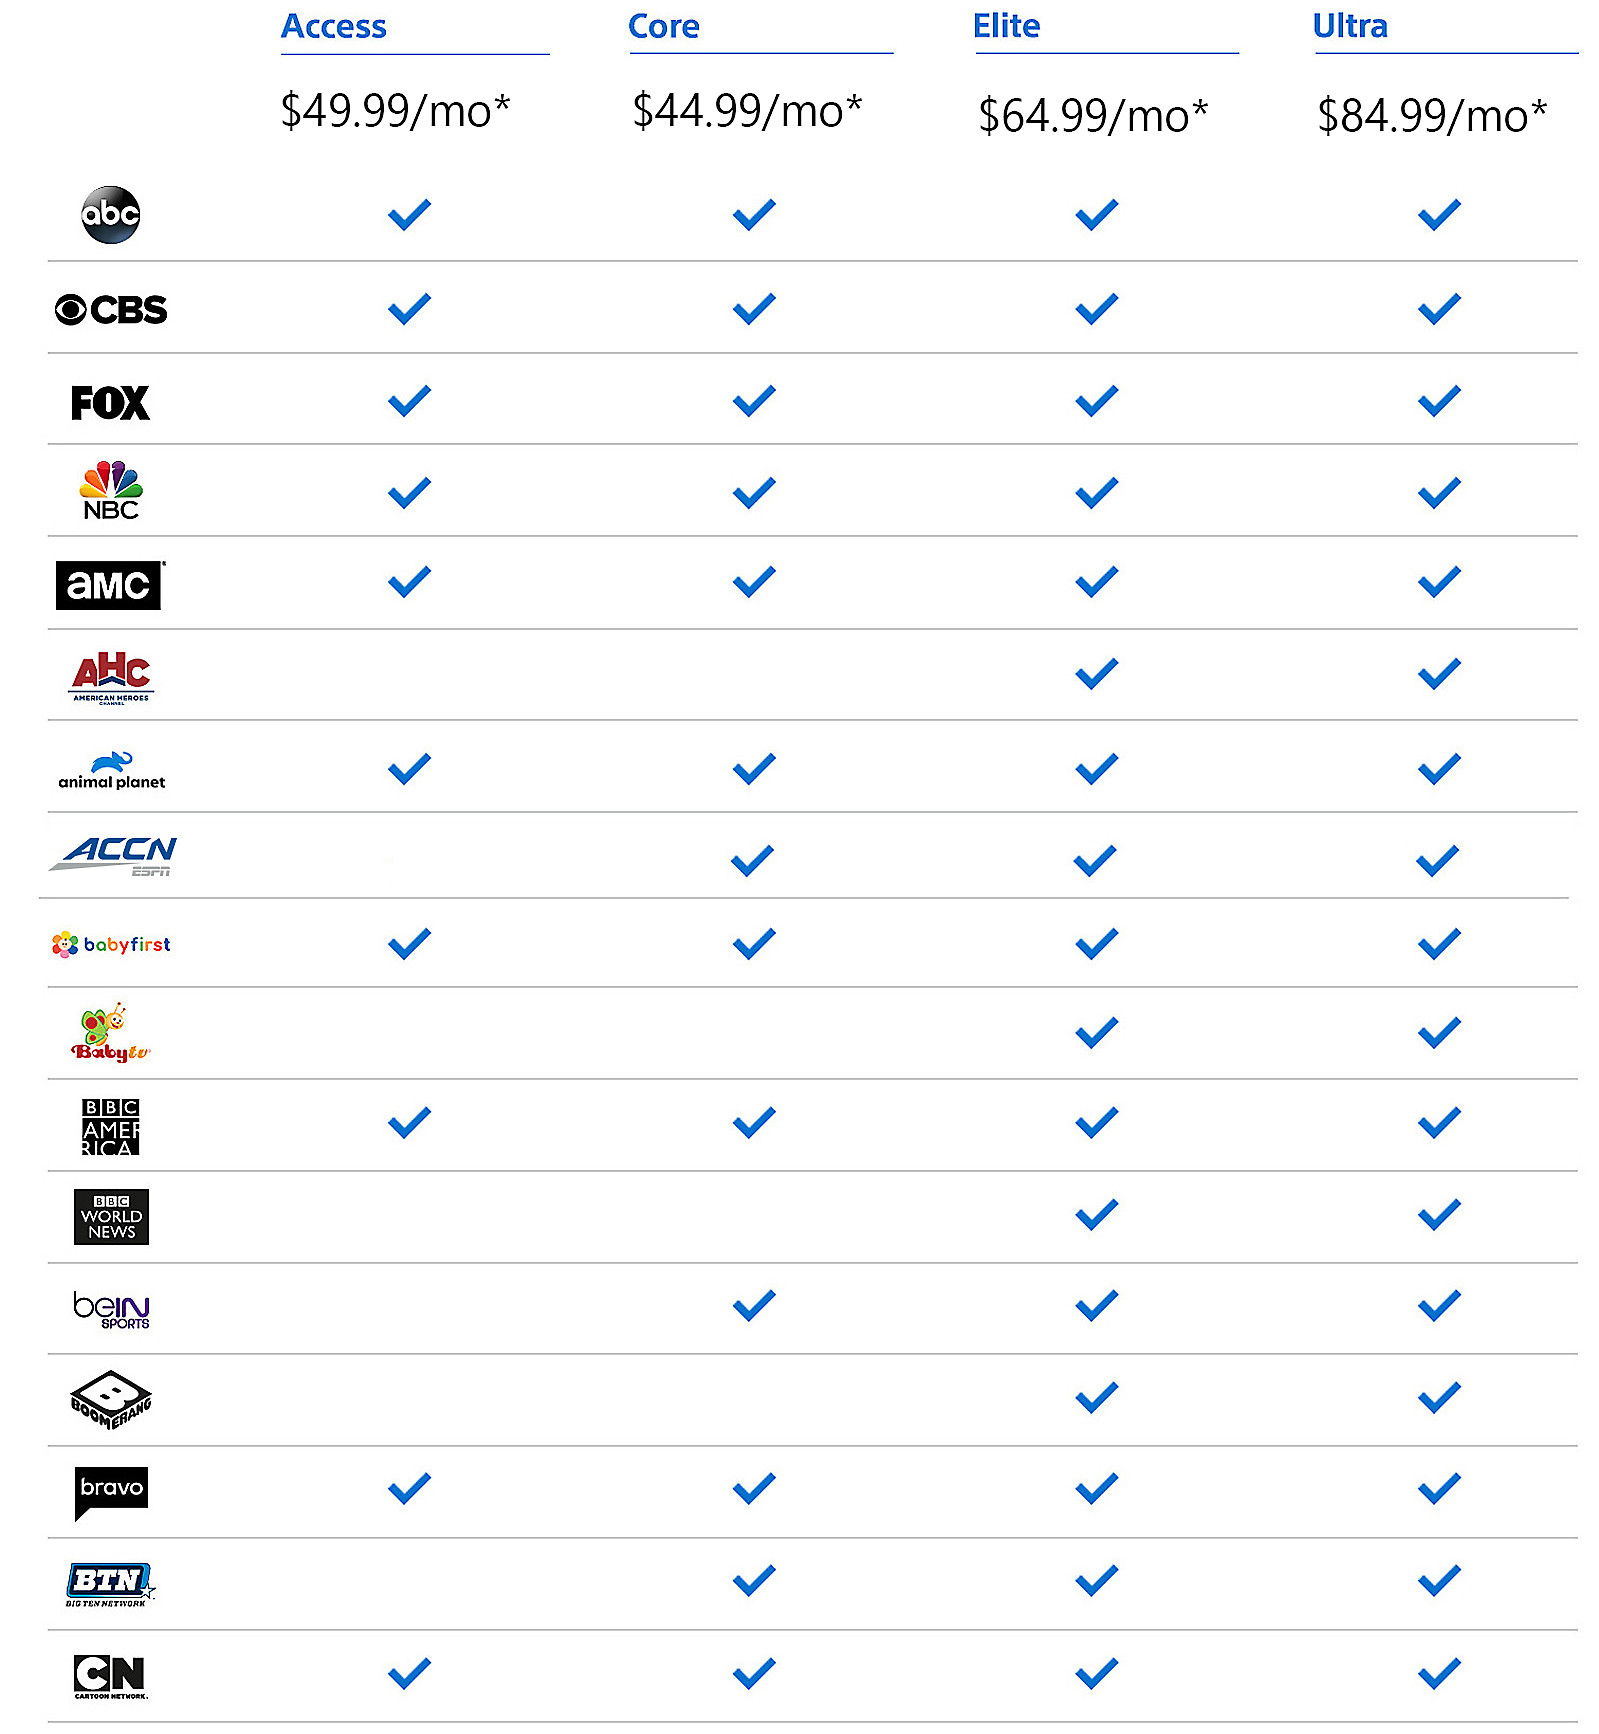What benefits does the Core package offer over the Access package? The Core package, priced at $44.99/mo, offers several advantages over the Access package at $49.99/mo. In addition to all the channels available in the Access package, the Core package includes BBC America and beIN SPORTS, providing access to a wider variety of programming, including international news and comprehensive sports coverage. If I were interested in children’s programming, which package should I choose? For the best children’s programming, consider the Elite package at $64.99/mo. This package includes channels like BabyFirst that are specifically tailored for young children, offering educational and entertaining content. Could you create a hypothetical scenario illustrating the differences? Imagine a family with children who enjoy watching educational programs and a dad who is a sports fanatic. By choosing the Elite package, they can keep their children engaged with BabyFirst while dad enjoys his favorite games on beIN SPORTS and ACCN. If they opt for the Ultra package, mom can also enjoy her preferred lifestyle programs included in this premium package, making it a perfect fit for all family members. What would happen if an alien came down to Earth and wanted to understand human culture through these packages? In a fantastical scenario where an alien lands on Earth and seeks to understand human culture, they would find the Ultra package most enlightening. With access to a variety of channels spanning news, sports, entertainment, and children’s programming, the Ultra package offers a comprehensive view of human interests and values, helping the alien grasp a more complete picture of Earth’s diverse cultural landscape. 